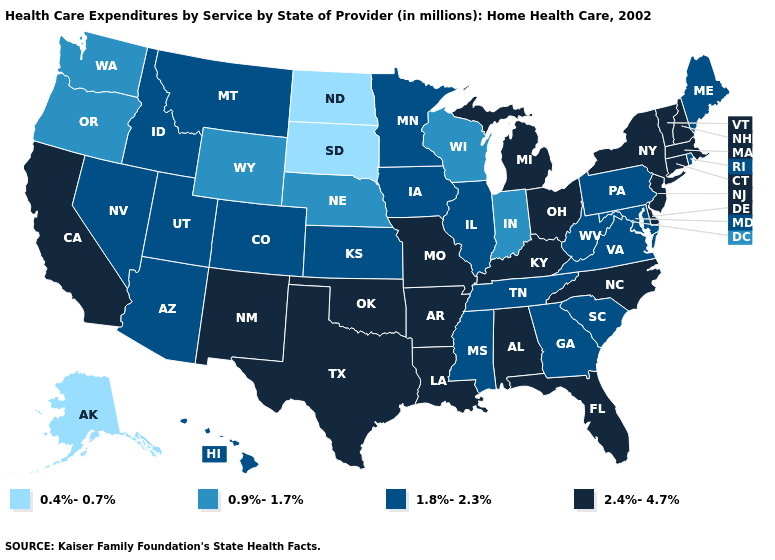What is the lowest value in the USA?
Be succinct. 0.4%-0.7%. What is the value of California?
Short answer required. 2.4%-4.7%. What is the value of Arizona?
Give a very brief answer. 1.8%-2.3%. What is the lowest value in the USA?
Short answer required. 0.4%-0.7%. What is the lowest value in states that border Mississippi?
Give a very brief answer. 1.8%-2.3%. What is the value of Tennessee?
Write a very short answer. 1.8%-2.3%. What is the value of Maine?
Concise answer only. 1.8%-2.3%. Does Utah have the lowest value in the USA?
Short answer required. No. Name the states that have a value in the range 0.9%-1.7%?
Write a very short answer. Indiana, Nebraska, Oregon, Washington, Wisconsin, Wyoming. What is the value of Maine?
Answer briefly. 1.8%-2.3%. Which states have the lowest value in the USA?
Answer briefly. Alaska, North Dakota, South Dakota. Among the states that border Missouri , which have the highest value?
Write a very short answer. Arkansas, Kentucky, Oklahoma. Is the legend a continuous bar?
Be succinct. No. Among the states that border Indiana , which have the lowest value?
Be succinct. Illinois. 